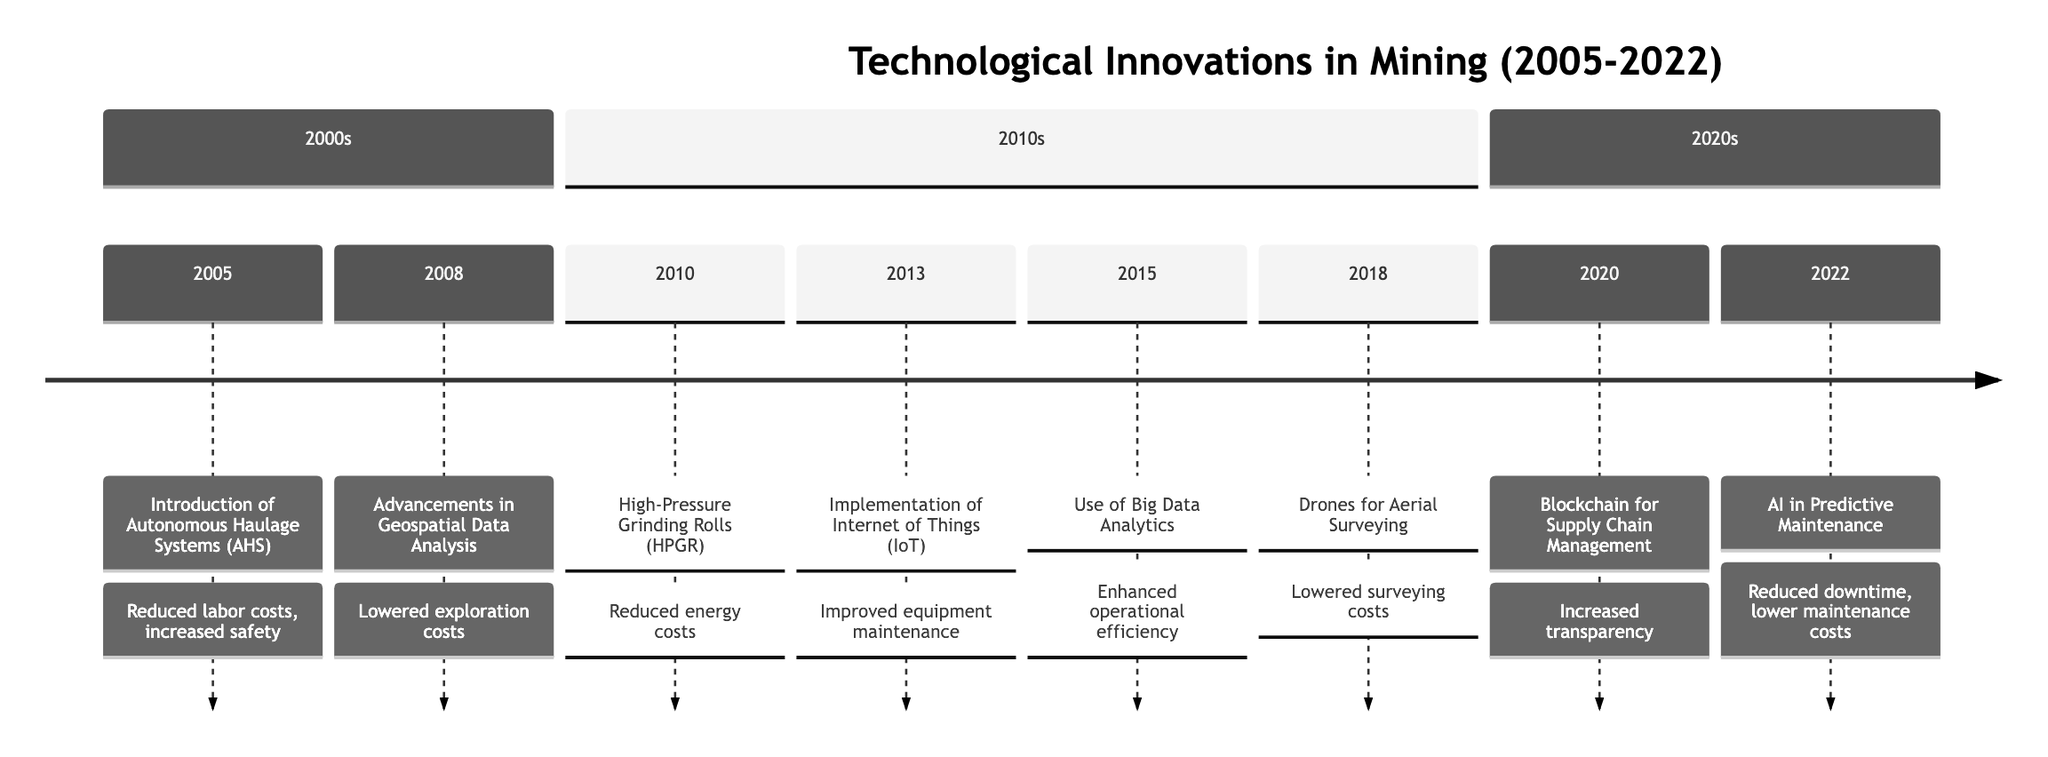What innovation was introduced in 2005? The diagram identifies "Introduction of Autonomous Haulage Systems (AHS)" as the innovation for the year 2005, appearing as the first entry in the timeline.
Answer: Introduction of Autonomous Haulage Systems (AHS) Which year saw the implementation of the Internet of Things? By scanning through the timeline, the year 2013 is marked with the innovation "Implementation of Internet of Things (IoT)", confirming the date of this technology’s implementation.
Answer: 2013 How many innovations were introduced in the 2010s? The timeline has five entries listed under the "2010s" section (2010, 2013, 2015, 2018), thus counting to determine the number of innovations introduced during this decade.
Answer: 5 What is the effect of Drones for Aerial Surveying according to the timeline? The timeline states that the effect of the "Drones for Aerial Surveying" innovation includes "Lowered surveying costs", which directly ties the innovation to its specific outcome.
Answer: Lowered surveying costs Which two innovations were implemented between 2015 and 2018? Looking at the timeline, the entries "Use of Big Data Analytics" and "Drones for Aerial Surveying" are notable during this interval, indicating the progression of technological advancements in mining.
Answer: Use of Big Data Analytics and Drones for Aerial Surveying What was the main benefit noted for the adoption of AI in 2022? In the timeline entry for 2022, the primary benefit of AI in Predictive Maintenance is described as "Reduced downtime, lower maintenance costs," allowing us to extract this key detail about its impact.
Answer: Reduced downtime, lower maintenance costs How did blockchain technology impact supply chain management in 2020? The timeline describes the introduction of blockchain technology in 2020 as leading to "Increased transparency," summarizing its importance in improving supply chain management.
Answer: Increased transparency What notable technological advancement was absent in the 2020s compared to the preceding decades? The timeline shows no new innovations listed for the years beyond 2022, indicating that while innovations were prevalent in prior years, there have been no further advancements post-2022 through this diagram's horizon.
Answer: No new innovations 